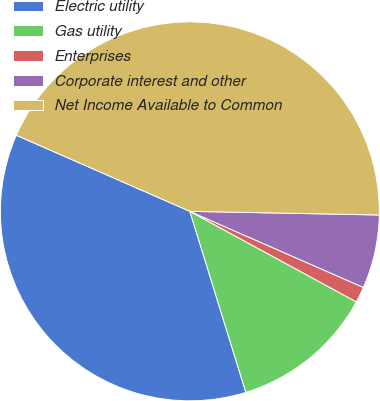Convert chart. <chart><loc_0><loc_0><loc_500><loc_500><pie_chart><fcel>Electric utility<fcel>Gas utility<fcel>Enterprises<fcel>Corporate interest and other<fcel>Net Income Available to Common<nl><fcel>36.35%<fcel>12.3%<fcel>1.35%<fcel>6.27%<fcel>43.73%<nl></chart> 